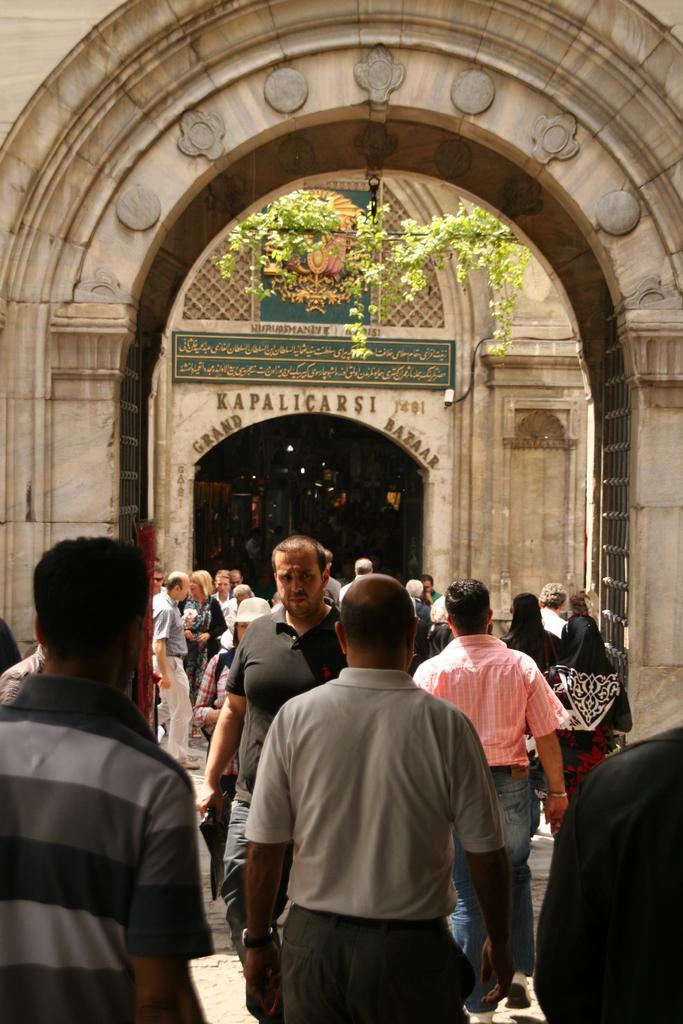Who or what can be seen in the image? There are people in the image. What architectural feature is present in the image? There are arches in the image. What can be found in the background of the image? There is text and objects in the background of the image. Can you see an ornament on the people's heads in the image? There is no mention of an ornament on the people's heads in the image. What is the people's reaction to the shame they feel in the image? There is no indication of shame or any emotional response in the image. 